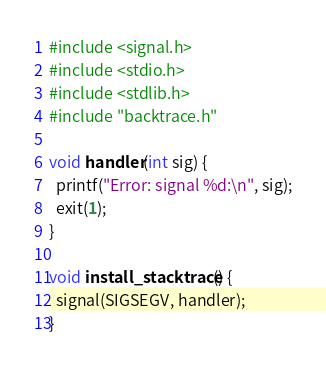Convert code to text. <code><loc_0><loc_0><loc_500><loc_500><_C++_>
#include <signal.h>
#include <stdio.h>
#include <stdlib.h>
#include "backtrace.h"

void handler(int sig) {
  printf("Error: signal %d:\n", sig);
  exit(1);
}

void install_stacktrace() {
  signal(SIGSEGV, handler);
}

</code> 